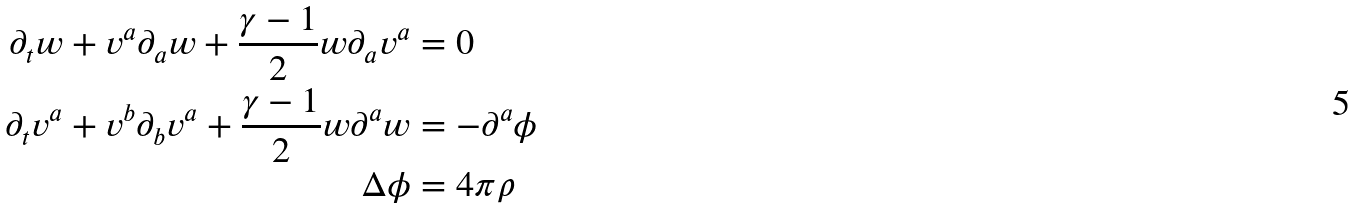Convert formula to latex. <formula><loc_0><loc_0><loc_500><loc_500>\partial _ { t } w + v ^ { a } \partial _ { a } w + \frac { \gamma - 1 } { 2 } w \partial _ { a } v ^ { a } & = 0 \\ \partial _ { t } v ^ { a } + v ^ { b } \partial _ { b } v ^ { a } + \frac { \gamma - 1 } { 2 } w \partial ^ { a } w & = - \partial ^ { a } \phi \\ \Delta \phi & = 4 \pi \rho</formula> 